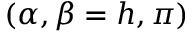Convert formula to latex. <formula><loc_0><loc_0><loc_500><loc_500>( \alpha , \beta = h , \pi )</formula> 